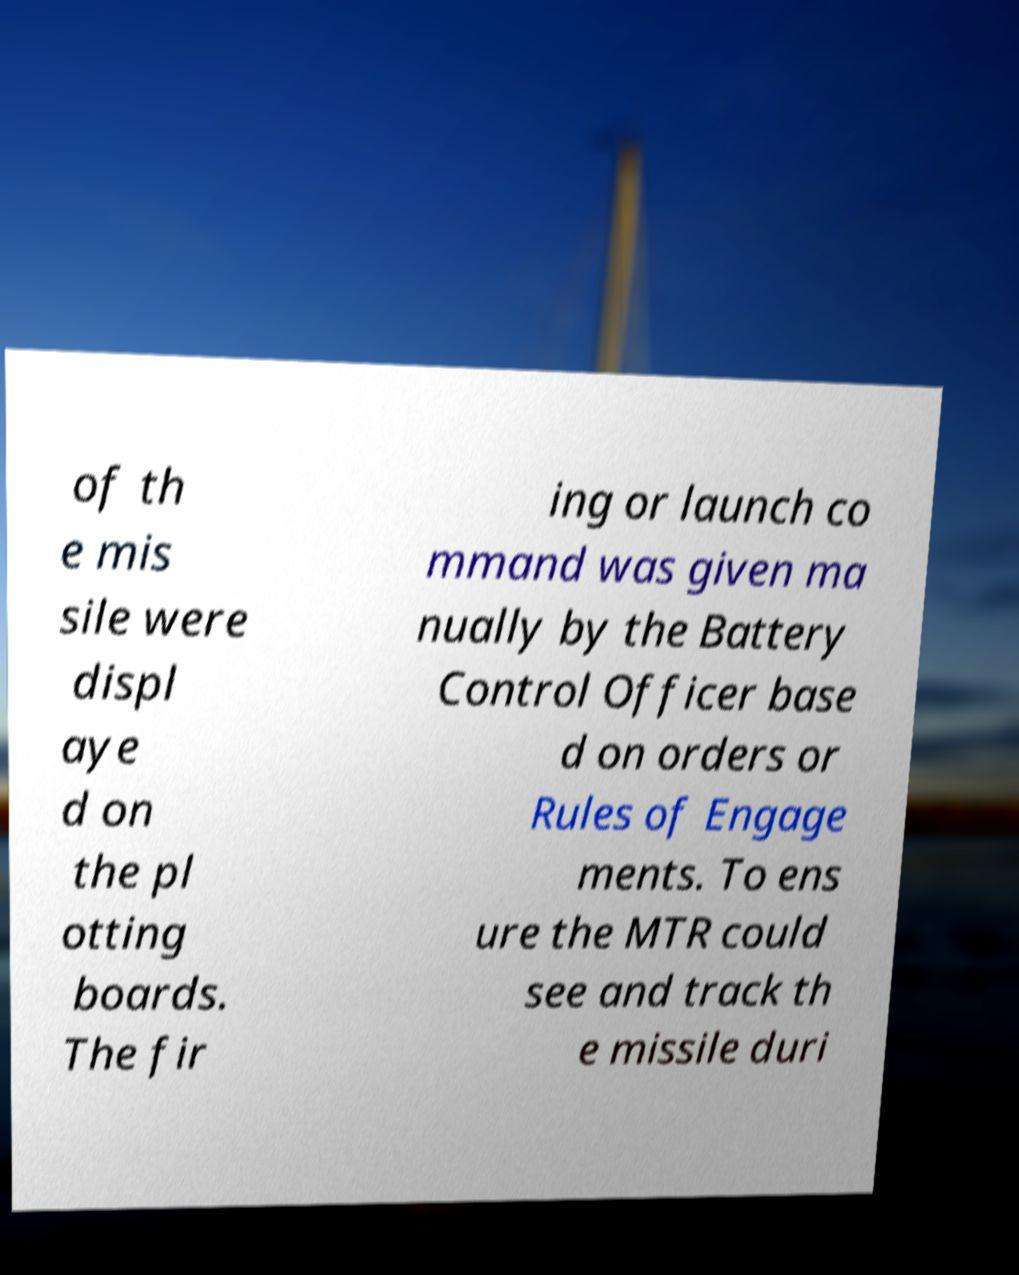For documentation purposes, I need the text within this image transcribed. Could you provide that? of th e mis sile were displ aye d on the pl otting boards. The fir ing or launch co mmand was given ma nually by the Battery Control Officer base d on orders or Rules of Engage ments. To ens ure the MTR could see and track th e missile duri 